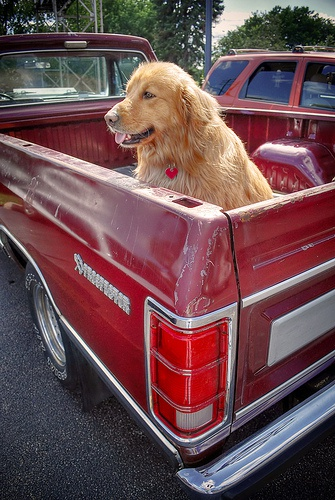Describe the objects in this image and their specific colors. I can see truck in purple, maroon, brown, and black tones, dog in purple, gray, tan, and brown tones, and car in purple, brown, darkblue, black, and gray tones in this image. 